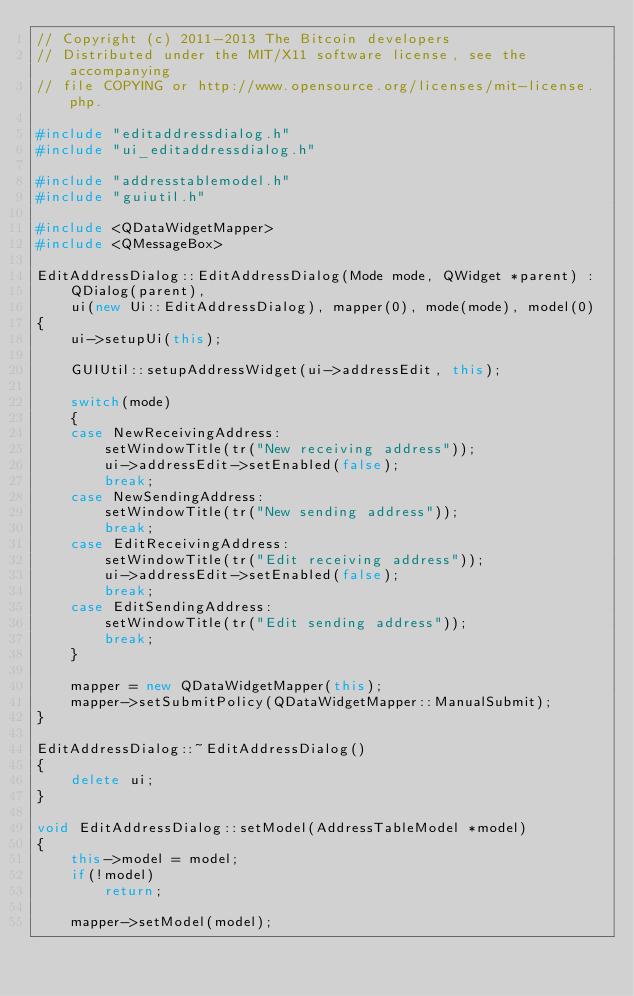<code> <loc_0><loc_0><loc_500><loc_500><_C++_>// Copyright (c) 2011-2013 The Bitcoin developers
// Distributed under the MIT/X11 software license, see the accompanying
// file COPYING or http://www.opensource.org/licenses/mit-license.php.

#include "editaddressdialog.h"
#include "ui_editaddressdialog.h"

#include "addresstablemodel.h"
#include "guiutil.h"

#include <QDataWidgetMapper>
#include <QMessageBox>

EditAddressDialog::EditAddressDialog(Mode mode, QWidget *parent) :
    QDialog(parent),
    ui(new Ui::EditAddressDialog), mapper(0), mode(mode), model(0)
{
    ui->setupUi(this);

    GUIUtil::setupAddressWidget(ui->addressEdit, this);

    switch(mode)
    {
    case NewReceivingAddress:
        setWindowTitle(tr("New receiving address"));
        ui->addressEdit->setEnabled(false);
        break;
    case NewSendingAddress:
        setWindowTitle(tr("New sending address"));
        break;
    case EditReceivingAddress:
        setWindowTitle(tr("Edit receiving address"));
        ui->addressEdit->setEnabled(false);
        break;
    case EditSendingAddress:
        setWindowTitle(tr("Edit sending address"));
        break;
    }

    mapper = new QDataWidgetMapper(this);
    mapper->setSubmitPolicy(QDataWidgetMapper::ManualSubmit);
}

EditAddressDialog::~EditAddressDialog()
{
    delete ui;
}

void EditAddressDialog::setModel(AddressTableModel *model)
{
    this->model = model;
    if(!model)
        return;

    mapper->setModel(model);</code> 